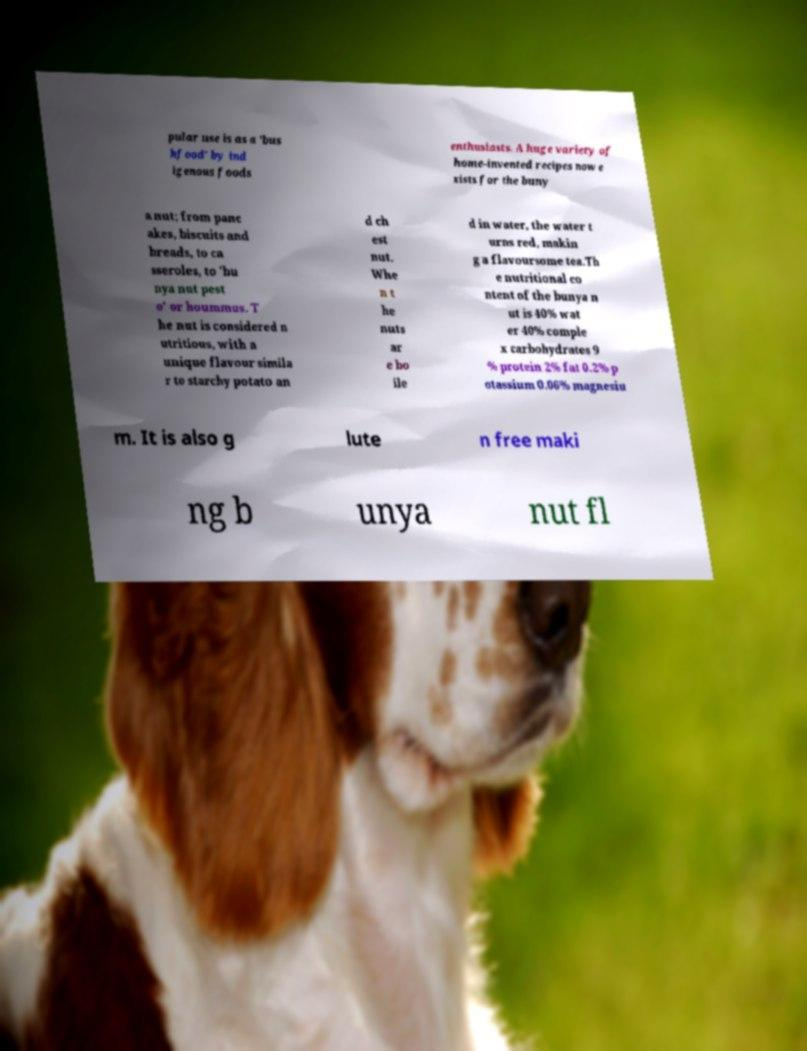Can you read and provide the text displayed in the image?This photo seems to have some interesting text. Can you extract and type it out for me? pular use is as a 'bus hfood' by ind igenous foods enthusiasts. A huge variety of home-invented recipes now e xists for the buny a nut; from panc akes, biscuits and breads, to ca sseroles, to 'bu nya nut pest o' or hoummus. T he nut is considered n utritious, with a unique flavour simila r to starchy potato an d ch est nut. Whe n t he nuts ar e bo ile d in water, the water t urns red, makin g a flavoursome tea.Th e nutritional co ntent of the bunya n ut is 40% wat er 40% comple x carbohydrates 9 % protein 2% fat 0.2% p otassium 0.06% magnesiu m. It is also g lute n free maki ng b unya nut fl 